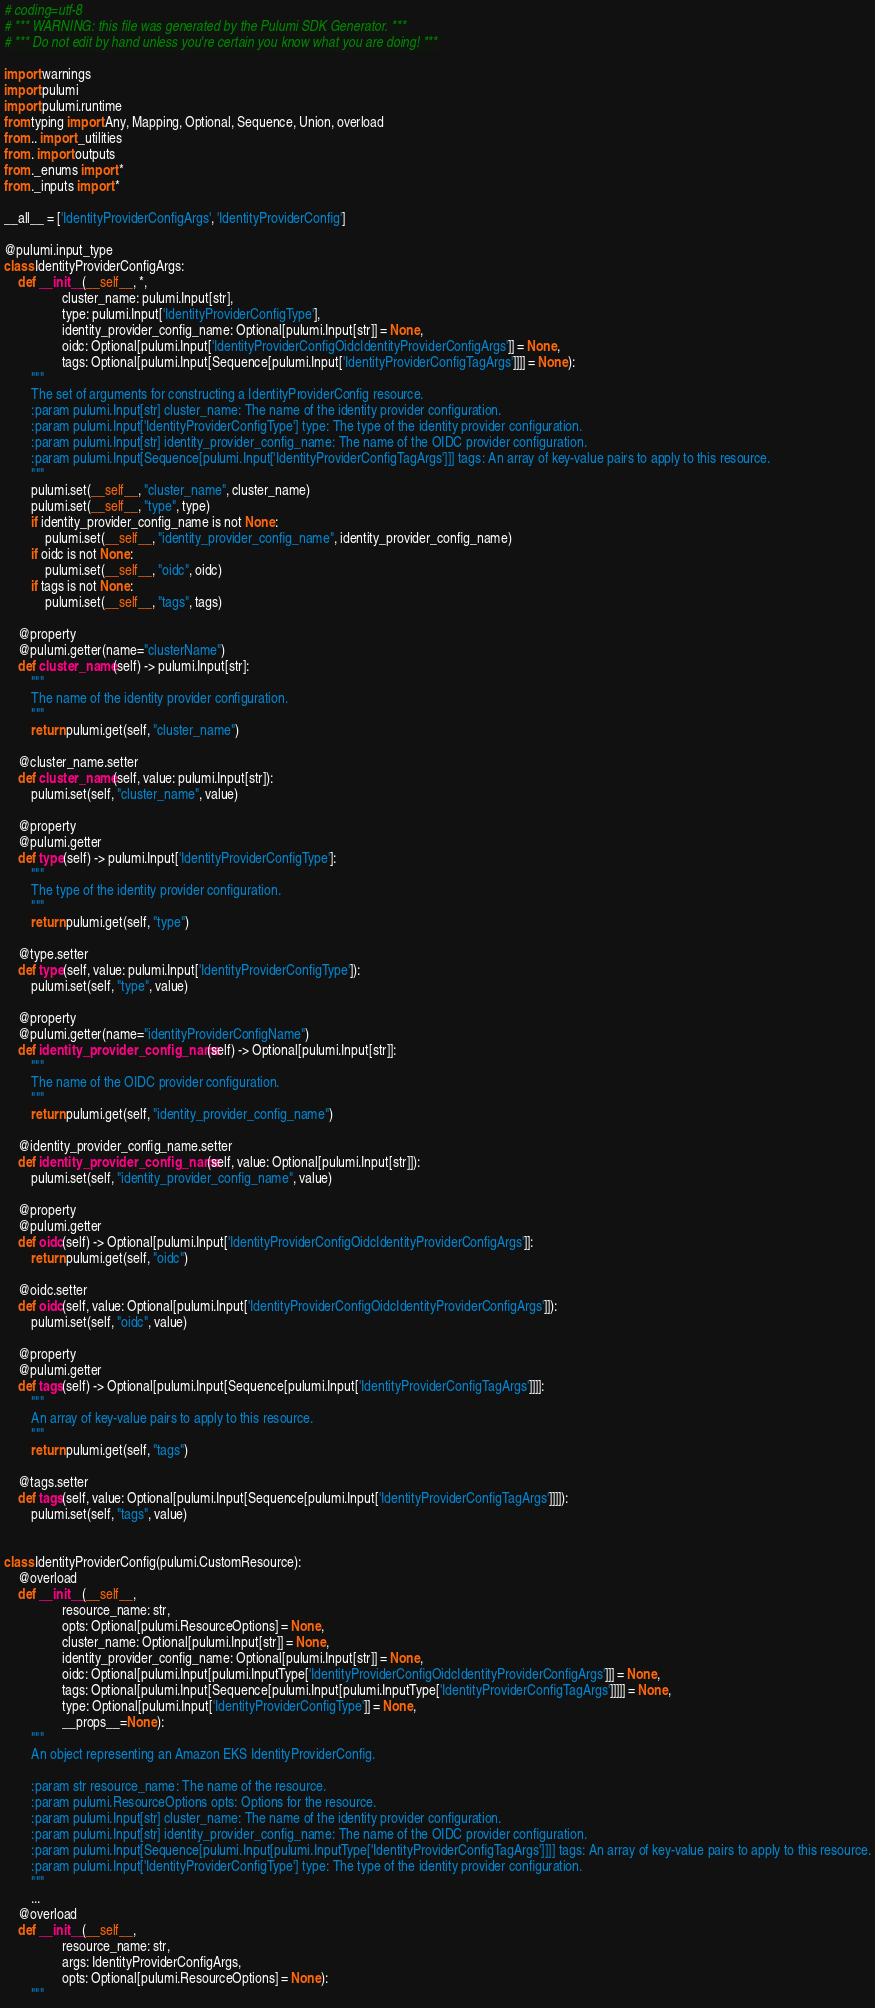Convert code to text. <code><loc_0><loc_0><loc_500><loc_500><_Python_># coding=utf-8
# *** WARNING: this file was generated by the Pulumi SDK Generator. ***
# *** Do not edit by hand unless you're certain you know what you are doing! ***

import warnings
import pulumi
import pulumi.runtime
from typing import Any, Mapping, Optional, Sequence, Union, overload
from .. import _utilities
from . import outputs
from ._enums import *
from ._inputs import *

__all__ = ['IdentityProviderConfigArgs', 'IdentityProviderConfig']

@pulumi.input_type
class IdentityProviderConfigArgs:
    def __init__(__self__, *,
                 cluster_name: pulumi.Input[str],
                 type: pulumi.Input['IdentityProviderConfigType'],
                 identity_provider_config_name: Optional[pulumi.Input[str]] = None,
                 oidc: Optional[pulumi.Input['IdentityProviderConfigOidcIdentityProviderConfigArgs']] = None,
                 tags: Optional[pulumi.Input[Sequence[pulumi.Input['IdentityProviderConfigTagArgs']]]] = None):
        """
        The set of arguments for constructing a IdentityProviderConfig resource.
        :param pulumi.Input[str] cluster_name: The name of the identity provider configuration.
        :param pulumi.Input['IdentityProviderConfigType'] type: The type of the identity provider configuration.
        :param pulumi.Input[str] identity_provider_config_name: The name of the OIDC provider configuration.
        :param pulumi.Input[Sequence[pulumi.Input['IdentityProviderConfigTagArgs']]] tags: An array of key-value pairs to apply to this resource.
        """
        pulumi.set(__self__, "cluster_name", cluster_name)
        pulumi.set(__self__, "type", type)
        if identity_provider_config_name is not None:
            pulumi.set(__self__, "identity_provider_config_name", identity_provider_config_name)
        if oidc is not None:
            pulumi.set(__self__, "oidc", oidc)
        if tags is not None:
            pulumi.set(__self__, "tags", tags)

    @property
    @pulumi.getter(name="clusterName")
    def cluster_name(self) -> pulumi.Input[str]:
        """
        The name of the identity provider configuration.
        """
        return pulumi.get(self, "cluster_name")

    @cluster_name.setter
    def cluster_name(self, value: pulumi.Input[str]):
        pulumi.set(self, "cluster_name", value)

    @property
    @pulumi.getter
    def type(self) -> pulumi.Input['IdentityProviderConfigType']:
        """
        The type of the identity provider configuration.
        """
        return pulumi.get(self, "type")

    @type.setter
    def type(self, value: pulumi.Input['IdentityProviderConfigType']):
        pulumi.set(self, "type", value)

    @property
    @pulumi.getter(name="identityProviderConfigName")
    def identity_provider_config_name(self) -> Optional[pulumi.Input[str]]:
        """
        The name of the OIDC provider configuration.
        """
        return pulumi.get(self, "identity_provider_config_name")

    @identity_provider_config_name.setter
    def identity_provider_config_name(self, value: Optional[pulumi.Input[str]]):
        pulumi.set(self, "identity_provider_config_name", value)

    @property
    @pulumi.getter
    def oidc(self) -> Optional[pulumi.Input['IdentityProviderConfigOidcIdentityProviderConfigArgs']]:
        return pulumi.get(self, "oidc")

    @oidc.setter
    def oidc(self, value: Optional[pulumi.Input['IdentityProviderConfigOidcIdentityProviderConfigArgs']]):
        pulumi.set(self, "oidc", value)

    @property
    @pulumi.getter
    def tags(self) -> Optional[pulumi.Input[Sequence[pulumi.Input['IdentityProviderConfigTagArgs']]]]:
        """
        An array of key-value pairs to apply to this resource.
        """
        return pulumi.get(self, "tags")

    @tags.setter
    def tags(self, value: Optional[pulumi.Input[Sequence[pulumi.Input['IdentityProviderConfigTagArgs']]]]):
        pulumi.set(self, "tags", value)


class IdentityProviderConfig(pulumi.CustomResource):
    @overload
    def __init__(__self__,
                 resource_name: str,
                 opts: Optional[pulumi.ResourceOptions] = None,
                 cluster_name: Optional[pulumi.Input[str]] = None,
                 identity_provider_config_name: Optional[pulumi.Input[str]] = None,
                 oidc: Optional[pulumi.Input[pulumi.InputType['IdentityProviderConfigOidcIdentityProviderConfigArgs']]] = None,
                 tags: Optional[pulumi.Input[Sequence[pulumi.Input[pulumi.InputType['IdentityProviderConfigTagArgs']]]]] = None,
                 type: Optional[pulumi.Input['IdentityProviderConfigType']] = None,
                 __props__=None):
        """
        An object representing an Amazon EKS IdentityProviderConfig.

        :param str resource_name: The name of the resource.
        :param pulumi.ResourceOptions opts: Options for the resource.
        :param pulumi.Input[str] cluster_name: The name of the identity provider configuration.
        :param pulumi.Input[str] identity_provider_config_name: The name of the OIDC provider configuration.
        :param pulumi.Input[Sequence[pulumi.Input[pulumi.InputType['IdentityProviderConfigTagArgs']]]] tags: An array of key-value pairs to apply to this resource.
        :param pulumi.Input['IdentityProviderConfigType'] type: The type of the identity provider configuration.
        """
        ...
    @overload
    def __init__(__self__,
                 resource_name: str,
                 args: IdentityProviderConfigArgs,
                 opts: Optional[pulumi.ResourceOptions] = None):
        """</code> 